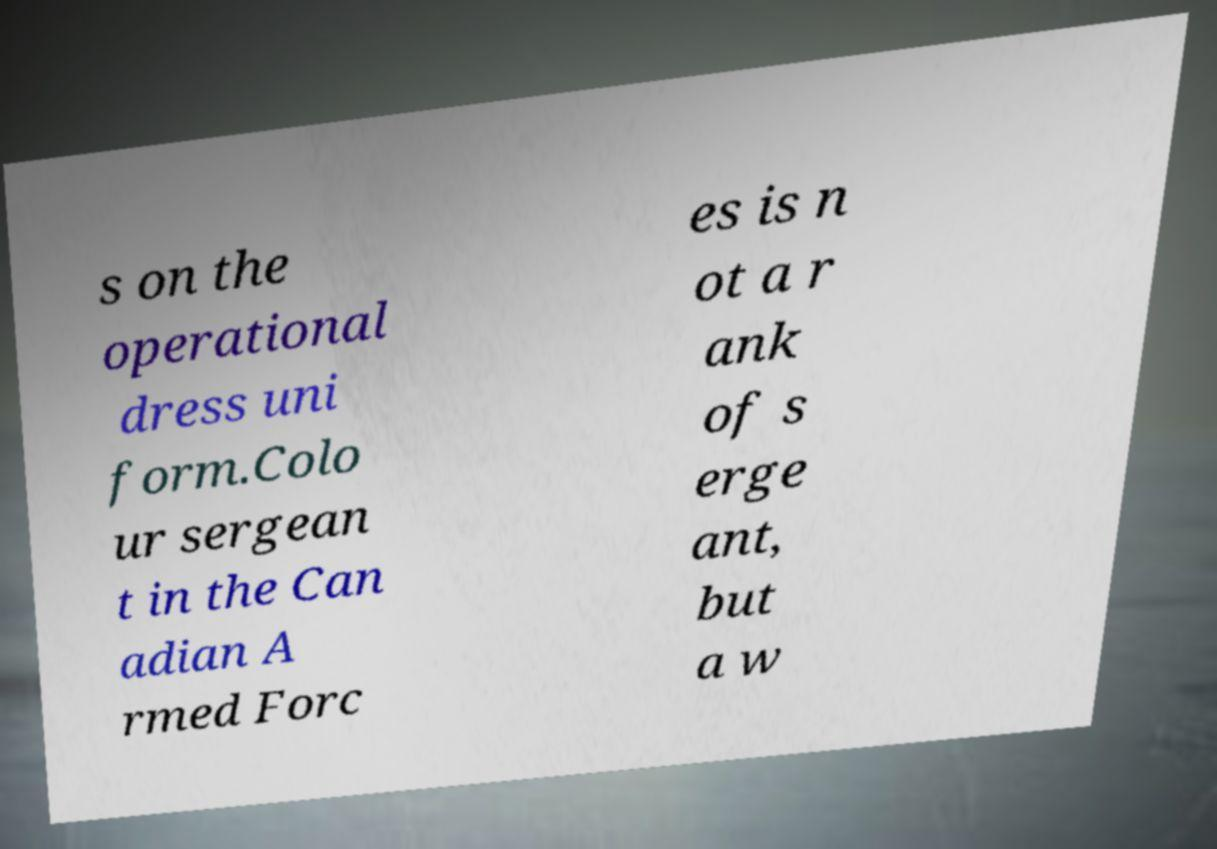For documentation purposes, I need the text within this image transcribed. Could you provide that? s on the operational dress uni form.Colo ur sergean t in the Can adian A rmed Forc es is n ot a r ank of s erge ant, but a w 